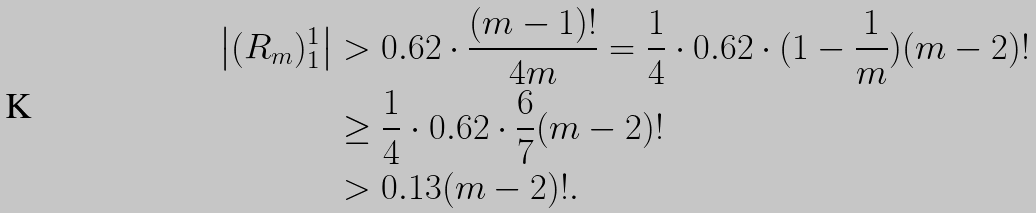<formula> <loc_0><loc_0><loc_500><loc_500>\left | ( R _ { m } ) _ { 1 } ^ { 1 } \right | & > 0 . 6 2 \cdot \frac { ( m - 1 ) ! } { 4 m } = \frac { 1 } { 4 } \cdot 0 . 6 2 \cdot ( 1 - \frac { 1 } { m } ) ( m - 2 ) ! \\ & \geq \frac { 1 } { 4 } \cdot 0 . 6 2 \cdot \frac { 6 } { 7 } ( m - 2 ) ! \\ & > 0 . 1 3 ( m - 2 ) ! .</formula> 